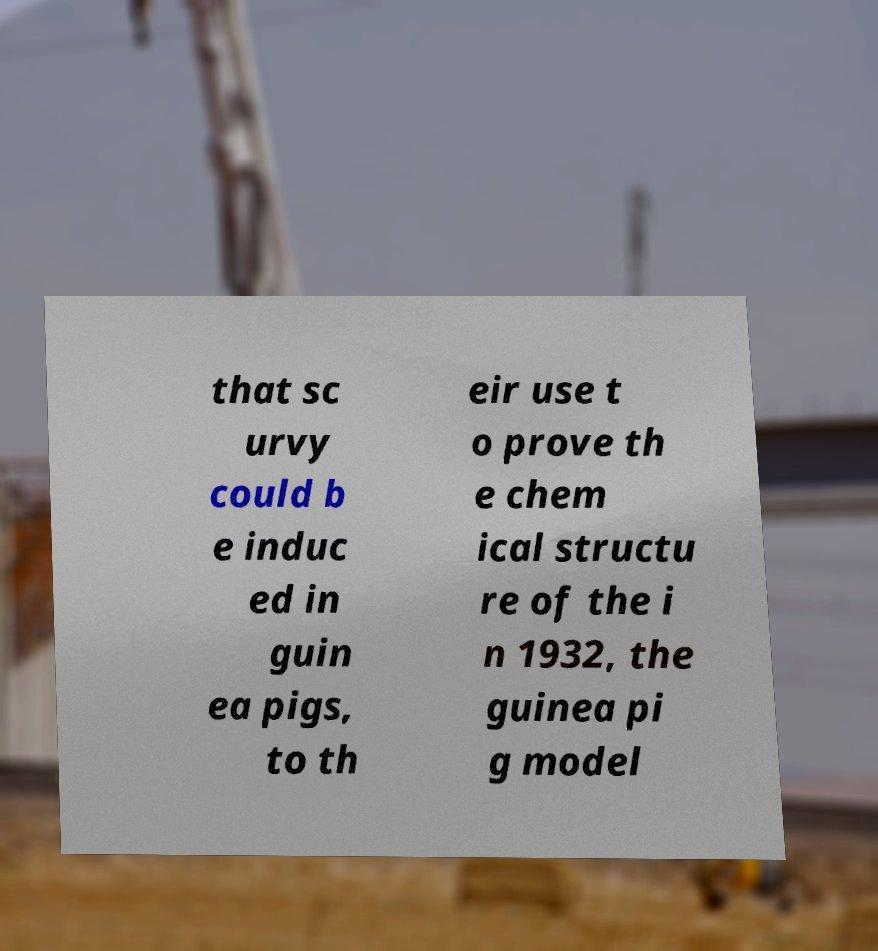What messages or text are displayed in this image? I need them in a readable, typed format. that sc urvy could b e induc ed in guin ea pigs, to th eir use t o prove th e chem ical structu re of the i n 1932, the guinea pi g model 